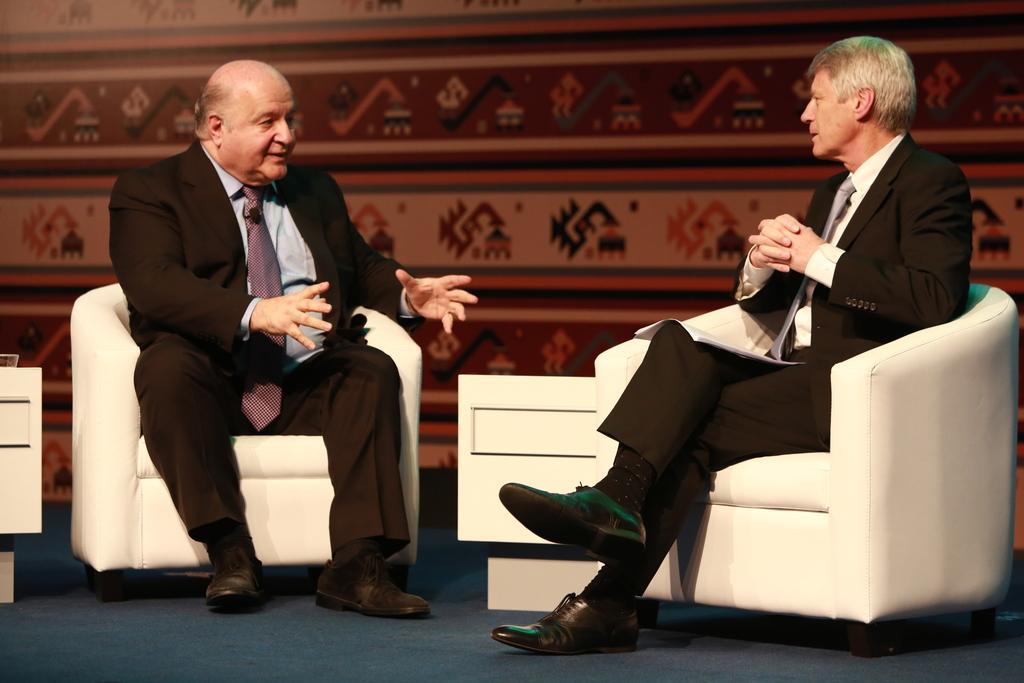Please provide a concise description of this image. Two persons are sitting in the sofa and talking each other they wear a black color coat Tie and shoes. 